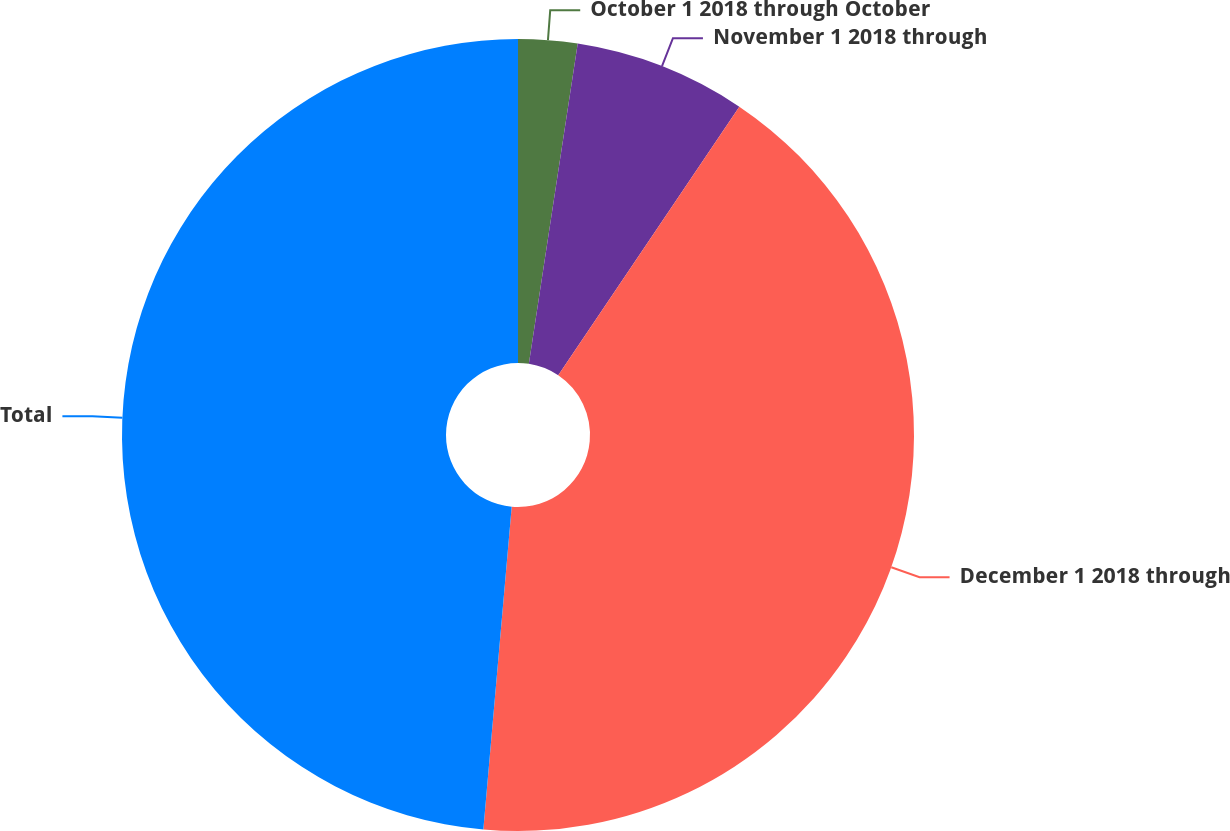<chart> <loc_0><loc_0><loc_500><loc_500><pie_chart><fcel>October 1 2018 through October<fcel>November 1 2018 through<fcel>December 1 2018 through<fcel>Total<nl><fcel>2.41%<fcel>7.03%<fcel>41.96%<fcel>48.61%<nl></chart> 